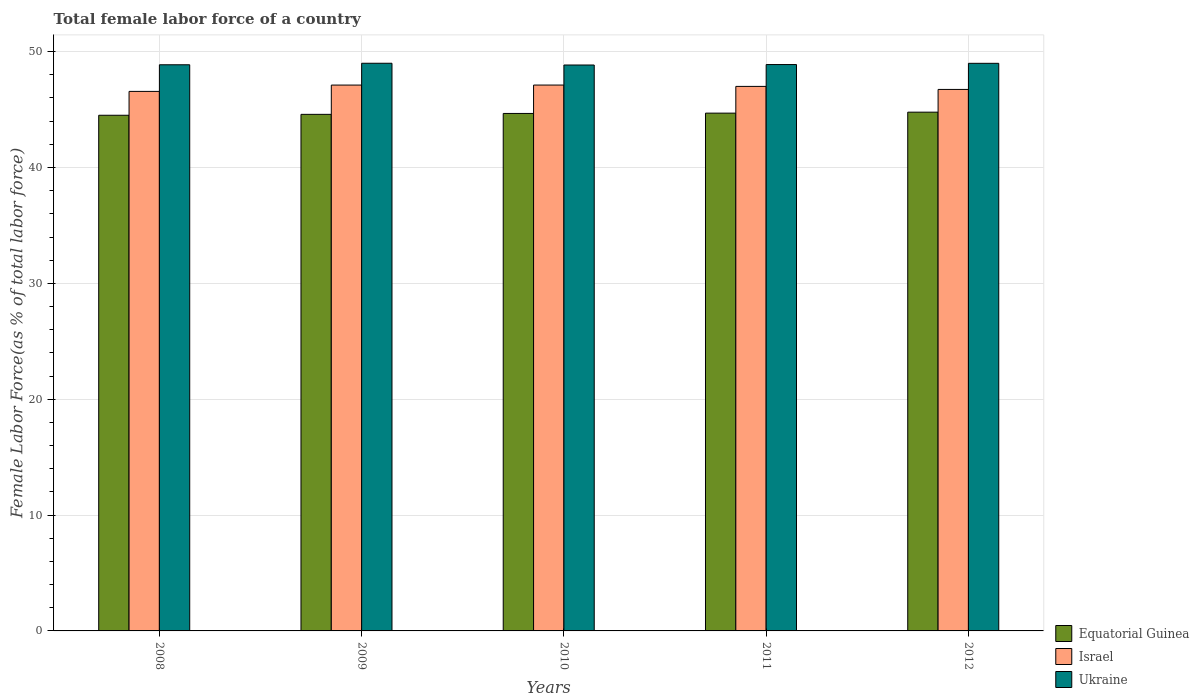How many different coloured bars are there?
Provide a succinct answer. 3. How many groups of bars are there?
Make the answer very short. 5. Are the number of bars per tick equal to the number of legend labels?
Provide a short and direct response. Yes. Are the number of bars on each tick of the X-axis equal?
Keep it short and to the point. Yes. How many bars are there on the 3rd tick from the left?
Your answer should be compact. 3. How many bars are there on the 2nd tick from the right?
Your response must be concise. 3. What is the label of the 5th group of bars from the left?
Your answer should be compact. 2012. What is the percentage of female labor force in Equatorial Guinea in 2012?
Your answer should be very brief. 44.77. Across all years, what is the maximum percentage of female labor force in Equatorial Guinea?
Give a very brief answer. 44.77. Across all years, what is the minimum percentage of female labor force in Ukraine?
Keep it short and to the point. 48.85. In which year was the percentage of female labor force in Israel maximum?
Make the answer very short. 2010. In which year was the percentage of female labor force in Israel minimum?
Offer a very short reply. 2008. What is the total percentage of female labor force in Ukraine in the graph?
Ensure brevity in your answer.  244.58. What is the difference between the percentage of female labor force in Ukraine in 2009 and that in 2010?
Keep it short and to the point. 0.15. What is the difference between the percentage of female labor force in Ukraine in 2008 and the percentage of female labor force in Equatorial Guinea in 2009?
Provide a succinct answer. 4.28. What is the average percentage of female labor force in Israel per year?
Offer a very short reply. 46.91. In the year 2009, what is the difference between the percentage of female labor force in Ukraine and percentage of female labor force in Israel?
Ensure brevity in your answer.  1.88. In how many years, is the percentage of female labor force in Equatorial Guinea greater than 40 %?
Give a very brief answer. 5. What is the ratio of the percentage of female labor force in Equatorial Guinea in 2010 to that in 2011?
Your response must be concise. 1. Is the difference between the percentage of female labor force in Ukraine in 2010 and 2012 greater than the difference between the percentage of female labor force in Israel in 2010 and 2012?
Keep it short and to the point. No. What is the difference between the highest and the second highest percentage of female labor force in Equatorial Guinea?
Make the answer very short. 0.08. What is the difference between the highest and the lowest percentage of female labor force in Israel?
Keep it short and to the point. 0.55. In how many years, is the percentage of female labor force in Israel greater than the average percentage of female labor force in Israel taken over all years?
Ensure brevity in your answer.  3. Is the sum of the percentage of female labor force in Israel in 2011 and 2012 greater than the maximum percentage of female labor force in Ukraine across all years?
Your answer should be compact. Yes. What does the 1st bar from the left in 2008 represents?
Your answer should be compact. Equatorial Guinea. What does the 1st bar from the right in 2012 represents?
Make the answer very short. Ukraine. How many bars are there?
Provide a succinct answer. 15. What is the difference between two consecutive major ticks on the Y-axis?
Give a very brief answer. 10. How many legend labels are there?
Provide a short and direct response. 3. What is the title of the graph?
Your answer should be very brief. Total female labor force of a country. Does "Italy" appear as one of the legend labels in the graph?
Your response must be concise. No. What is the label or title of the Y-axis?
Your answer should be compact. Female Labor Force(as % of total labor force). What is the Female Labor Force(as % of total labor force) in Equatorial Guinea in 2008?
Keep it short and to the point. 44.51. What is the Female Labor Force(as % of total labor force) of Israel in 2008?
Make the answer very short. 46.57. What is the Female Labor Force(as % of total labor force) in Ukraine in 2008?
Provide a succinct answer. 48.87. What is the Female Labor Force(as % of total labor force) of Equatorial Guinea in 2009?
Keep it short and to the point. 44.59. What is the Female Labor Force(as % of total labor force) of Israel in 2009?
Offer a very short reply. 47.11. What is the Female Labor Force(as % of total labor force) in Ukraine in 2009?
Your answer should be compact. 49. What is the Female Labor Force(as % of total labor force) of Equatorial Guinea in 2010?
Ensure brevity in your answer.  44.66. What is the Female Labor Force(as % of total labor force) in Israel in 2010?
Offer a terse response. 47.11. What is the Female Labor Force(as % of total labor force) in Ukraine in 2010?
Ensure brevity in your answer.  48.85. What is the Female Labor Force(as % of total labor force) of Equatorial Guinea in 2011?
Give a very brief answer. 44.69. What is the Female Labor Force(as % of total labor force) in Israel in 2011?
Your answer should be very brief. 47. What is the Female Labor Force(as % of total labor force) in Ukraine in 2011?
Give a very brief answer. 48.88. What is the Female Labor Force(as % of total labor force) of Equatorial Guinea in 2012?
Your answer should be compact. 44.77. What is the Female Labor Force(as % of total labor force) in Israel in 2012?
Offer a terse response. 46.74. What is the Female Labor Force(as % of total labor force) of Ukraine in 2012?
Provide a succinct answer. 48.99. Across all years, what is the maximum Female Labor Force(as % of total labor force) in Equatorial Guinea?
Provide a short and direct response. 44.77. Across all years, what is the maximum Female Labor Force(as % of total labor force) in Israel?
Your answer should be very brief. 47.11. Across all years, what is the maximum Female Labor Force(as % of total labor force) in Ukraine?
Make the answer very short. 49. Across all years, what is the minimum Female Labor Force(as % of total labor force) in Equatorial Guinea?
Provide a succinct answer. 44.51. Across all years, what is the minimum Female Labor Force(as % of total labor force) in Israel?
Ensure brevity in your answer.  46.57. Across all years, what is the minimum Female Labor Force(as % of total labor force) in Ukraine?
Offer a terse response. 48.85. What is the total Female Labor Force(as % of total labor force) of Equatorial Guinea in the graph?
Offer a terse response. 223.22. What is the total Female Labor Force(as % of total labor force) of Israel in the graph?
Make the answer very short. 234.53. What is the total Female Labor Force(as % of total labor force) of Ukraine in the graph?
Your answer should be very brief. 244.58. What is the difference between the Female Labor Force(as % of total labor force) of Equatorial Guinea in 2008 and that in 2009?
Your response must be concise. -0.08. What is the difference between the Female Labor Force(as % of total labor force) in Israel in 2008 and that in 2009?
Provide a succinct answer. -0.55. What is the difference between the Female Labor Force(as % of total labor force) of Ukraine in 2008 and that in 2009?
Your answer should be compact. -0.13. What is the difference between the Female Labor Force(as % of total labor force) in Equatorial Guinea in 2008 and that in 2010?
Your answer should be very brief. -0.16. What is the difference between the Female Labor Force(as % of total labor force) of Israel in 2008 and that in 2010?
Your response must be concise. -0.55. What is the difference between the Female Labor Force(as % of total labor force) in Ukraine in 2008 and that in 2010?
Make the answer very short. 0.02. What is the difference between the Female Labor Force(as % of total labor force) in Equatorial Guinea in 2008 and that in 2011?
Your response must be concise. -0.18. What is the difference between the Female Labor Force(as % of total labor force) of Israel in 2008 and that in 2011?
Make the answer very short. -0.43. What is the difference between the Female Labor Force(as % of total labor force) in Ukraine in 2008 and that in 2011?
Provide a succinct answer. -0.02. What is the difference between the Female Labor Force(as % of total labor force) of Equatorial Guinea in 2008 and that in 2012?
Provide a short and direct response. -0.27. What is the difference between the Female Labor Force(as % of total labor force) of Israel in 2008 and that in 2012?
Your answer should be compact. -0.17. What is the difference between the Female Labor Force(as % of total labor force) of Ukraine in 2008 and that in 2012?
Provide a short and direct response. -0.12. What is the difference between the Female Labor Force(as % of total labor force) of Equatorial Guinea in 2009 and that in 2010?
Your answer should be very brief. -0.08. What is the difference between the Female Labor Force(as % of total labor force) of Israel in 2009 and that in 2010?
Give a very brief answer. -0. What is the difference between the Female Labor Force(as % of total labor force) in Ukraine in 2009 and that in 2010?
Your answer should be very brief. 0.15. What is the difference between the Female Labor Force(as % of total labor force) of Equatorial Guinea in 2009 and that in 2011?
Keep it short and to the point. -0.11. What is the difference between the Female Labor Force(as % of total labor force) of Israel in 2009 and that in 2011?
Your answer should be compact. 0.12. What is the difference between the Female Labor Force(as % of total labor force) of Ukraine in 2009 and that in 2011?
Your answer should be very brief. 0.11. What is the difference between the Female Labor Force(as % of total labor force) in Equatorial Guinea in 2009 and that in 2012?
Give a very brief answer. -0.19. What is the difference between the Female Labor Force(as % of total labor force) in Israel in 2009 and that in 2012?
Give a very brief answer. 0.38. What is the difference between the Female Labor Force(as % of total labor force) in Ukraine in 2009 and that in 2012?
Ensure brevity in your answer.  0.01. What is the difference between the Female Labor Force(as % of total labor force) of Equatorial Guinea in 2010 and that in 2011?
Provide a succinct answer. -0.03. What is the difference between the Female Labor Force(as % of total labor force) in Israel in 2010 and that in 2011?
Your answer should be very brief. 0.12. What is the difference between the Female Labor Force(as % of total labor force) in Ukraine in 2010 and that in 2011?
Your answer should be very brief. -0.04. What is the difference between the Female Labor Force(as % of total labor force) in Equatorial Guinea in 2010 and that in 2012?
Provide a short and direct response. -0.11. What is the difference between the Female Labor Force(as % of total labor force) of Israel in 2010 and that in 2012?
Offer a terse response. 0.38. What is the difference between the Female Labor Force(as % of total labor force) in Ukraine in 2010 and that in 2012?
Offer a very short reply. -0.14. What is the difference between the Female Labor Force(as % of total labor force) of Equatorial Guinea in 2011 and that in 2012?
Your answer should be very brief. -0.08. What is the difference between the Female Labor Force(as % of total labor force) of Israel in 2011 and that in 2012?
Offer a very short reply. 0.26. What is the difference between the Female Labor Force(as % of total labor force) of Ukraine in 2011 and that in 2012?
Your answer should be very brief. -0.11. What is the difference between the Female Labor Force(as % of total labor force) of Equatorial Guinea in 2008 and the Female Labor Force(as % of total labor force) of Israel in 2009?
Provide a short and direct response. -2.61. What is the difference between the Female Labor Force(as % of total labor force) in Equatorial Guinea in 2008 and the Female Labor Force(as % of total labor force) in Ukraine in 2009?
Your answer should be compact. -4.49. What is the difference between the Female Labor Force(as % of total labor force) of Israel in 2008 and the Female Labor Force(as % of total labor force) of Ukraine in 2009?
Your response must be concise. -2.43. What is the difference between the Female Labor Force(as % of total labor force) of Equatorial Guinea in 2008 and the Female Labor Force(as % of total labor force) of Israel in 2010?
Your response must be concise. -2.61. What is the difference between the Female Labor Force(as % of total labor force) in Equatorial Guinea in 2008 and the Female Labor Force(as % of total labor force) in Ukraine in 2010?
Offer a terse response. -4.34. What is the difference between the Female Labor Force(as % of total labor force) of Israel in 2008 and the Female Labor Force(as % of total labor force) of Ukraine in 2010?
Keep it short and to the point. -2.28. What is the difference between the Female Labor Force(as % of total labor force) in Equatorial Guinea in 2008 and the Female Labor Force(as % of total labor force) in Israel in 2011?
Keep it short and to the point. -2.49. What is the difference between the Female Labor Force(as % of total labor force) in Equatorial Guinea in 2008 and the Female Labor Force(as % of total labor force) in Ukraine in 2011?
Give a very brief answer. -4.38. What is the difference between the Female Labor Force(as % of total labor force) in Israel in 2008 and the Female Labor Force(as % of total labor force) in Ukraine in 2011?
Provide a short and direct response. -2.32. What is the difference between the Female Labor Force(as % of total labor force) in Equatorial Guinea in 2008 and the Female Labor Force(as % of total labor force) in Israel in 2012?
Give a very brief answer. -2.23. What is the difference between the Female Labor Force(as % of total labor force) in Equatorial Guinea in 2008 and the Female Labor Force(as % of total labor force) in Ukraine in 2012?
Your answer should be very brief. -4.48. What is the difference between the Female Labor Force(as % of total labor force) in Israel in 2008 and the Female Labor Force(as % of total labor force) in Ukraine in 2012?
Give a very brief answer. -2.42. What is the difference between the Female Labor Force(as % of total labor force) of Equatorial Guinea in 2009 and the Female Labor Force(as % of total labor force) of Israel in 2010?
Provide a short and direct response. -2.53. What is the difference between the Female Labor Force(as % of total labor force) in Equatorial Guinea in 2009 and the Female Labor Force(as % of total labor force) in Ukraine in 2010?
Offer a very short reply. -4.26. What is the difference between the Female Labor Force(as % of total labor force) in Israel in 2009 and the Female Labor Force(as % of total labor force) in Ukraine in 2010?
Give a very brief answer. -1.73. What is the difference between the Female Labor Force(as % of total labor force) in Equatorial Guinea in 2009 and the Female Labor Force(as % of total labor force) in Israel in 2011?
Your response must be concise. -2.41. What is the difference between the Female Labor Force(as % of total labor force) in Equatorial Guinea in 2009 and the Female Labor Force(as % of total labor force) in Ukraine in 2011?
Keep it short and to the point. -4.3. What is the difference between the Female Labor Force(as % of total labor force) of Israel in 2009 and the Female Labor Force(as % of total labor force) of Ukraine in 2011?
Provide a short and direct response. -1.77. What is the difference between the Female Labor Force(as % of total labor force) of Equatorial Guinea in 2009 and the Female Labor Force(as % of total labor force) of Israel in 2012?
Offer a very short reply. -2.15. What is the difference between the Female Labor Force(as % of total labor force) in Equatorial Guinea in 2009 and the Female Labor Force(as % of total labor force) in Ukraine in 2012?
Your answer should be compact. -4.4. What is the difference between the Female Labor Force(as % of total labor force) of Israel in 2009 and the Female Labor Force(as % of total labor force) of Ukraine in 2012?
Your response must be concise. -1.88. What is the difference between the Female Labor Force(as % of total labor force) in Equatorial Guinea in 2010 and the Female Labor Force(as % of total labor force) in Israel in 2011?
Provide a short and direct response. -2.33. What is the difference between the Female Labor Force(as % of total labor force) in Equatorial Guinea in 2010 and the Female Labor Force(as % of total labor force) in Ukraine in 2011?
Provide a succinct answer. -4.22. What is the difference between the Female Labor Force(as % of total labor force) in Israel in 2010 and the Female Labor Force(as % of total labor force) in Ukraine in 2011?
Ensure brevity in your answer.  -1.77. What is the difference between the Female Labor Force(as % of total labor force) in Equatorial Guinea in 2010 and the Female Labor Force(as % of total labor force) in Israel in 2012?
Make the answer very short. -2.07. What is the difference between the Female Labor Force(as % of total labor force) in Equatorial Guinea in 2010 and the Female Labor Force(as % of total labor force) in Ukraine in 2012?
Keep it short and to the point. -4.33. What is the difference between the Female Labor Force(as % of total labor force) of Israel in 2010 and the Female Labor Force(as % of total labor force) of Ukraine in 2012?
Your answer should be compact. -1.88. What is the difference between the Female Labor Force(as % of total labor force) of Equatorial Guinea in 2011 and the Female Labor Force(as % of total labor force) of Israel in 2012?
Keep it short and to the point. -2.05. What is the difference between the Female Labor Force(as % of total labor force) in Equatorial Guinea in 2011 and the Female Labor Force(as % of total labor force) in Ukraine in 2012?
Offer a terse response. -4.3. What is the difference between the Female Labor Force(as % of total labor force) in Israel in 2011 and the Female Labor Force(as % of total labor force) in Ukraine in 2012?
Provide a succinct answer. -1.99. What is the average Female Labor Force(as % of total labor force) in Equatorial Guinea per year?
Provide a short and direct response. 44.64. What is the average Female Labor Force(as % of total labor force) in Israel per year?
Provide a short and direct response. 46.91. What is the average Female Labor Force(as % of total labor force) of Ukraine per year?
Keep it short and to the point. 48.92. In the year 2008, what is the difference between the Female Labor Force(as % of total labor force) in Equatorial Guinea and Female Labor Force(as % of total labor force) in Israel?
Offer a very short reply. -2.06. In the year 2008, what is the difference between the Female Labor Force(as % of total labor force) in Equatorial Guinea and Female Labor Force(as % of total labor force) in Ukraine?
Provide a succinct answer. -4.36. In the year 2008, what is the difference between the Female Labor Force(as % of total labor force) of Israel and Female Labor Force(as % of total labor force) of Ukraine?
Make the answer very short. -2.3. In the year 2009, what is the difference between the Female Labor Force(as % of total labor force) of Equatorial Guinea and Female Labor Force(as % of total labor force) of Israel?
Offer a terse response. -2.53. In the year 2009, what is the difference between the Female Labor Force(as % of total labor force) in Equatorial Guinea and Female Labor Force(as % of total labor force) in Ukraine?
Provide a short and direct response. -4.41. In the year 2009, what is the difference between the Female Labor Force(as % of total labor force) of Israel and Female Labor Force(as % of total labor force) of Ukraine?
Your answer should be very brief. -1.88. In the year 2010, what is the difference between the Female Labor Force(as % of total labor force) of Equatorial Guinea and Female Labor Force(as % of total labor force) of Israel?
Provide a short and direct response. -2.45. In the year 2010, what is the difference between the Female Labor Force(as % of total labor force) of Equatorial Guinea and Female Labor Force(as % of total labor force) of Ukraine?
Provide a succinct answer. -4.18. In the year 2010, what is the difference between the Female Labor Force(as % of total labor force) of Israel and Female Labor Force(as % of total labor force) of Ukraine?
Make the answer very short. -1.73. In the year 2011, what is the difference between the Female Labor Force(as % of total labor force) of Equatorial Guinea and Female Labor Force(as % of total labor force) of Israel?
Provide a short and direct response. -2.31. In the year 2011, what is the difference between the Female Labor Force(as % of total labor force) in Equatorial Guinea and Female Labor Force(as % of total labor force) in Ukraine?
Keep it short and to the point. -4.19. In the year 2011, what is the difference between the Female Labor Force(as % of total labor force) in Israel and Female Labor Force(as % of total labor force) in Ukraine?
Keep it short and to the point. -1.89. In the year 2012, what is the difference between the Female Labor Force(as % of total labor force) in Equatorial Guinea and Female Labor Force(as % of total labor force) in Israel?
Your response must be concise. -1.96. In the year 2012, what is the difference between the Female Labor Force(as % of total labor force) in Equatorial Guinea and Female Labor Force(as % of total labor force) in Ukraine?
Provide a short and direct response. -4.22. In the year 2012, what is the difference between the Female Labor Force(as % of total labor force) in Israel and Female Labor Force(as % of total labor force) in Ukraine?
Provide a succinct answer. -2.25. What is the ratio of the Female Labor Force(as % of total labor force) in Equatorial Guinea in 2008 to that in 2009?
Your response must be concise. 1. What is the ratio of the Female Labor Force(as % of total labor force) in Israel in 2008 to that in 2009?
Your answer should be compact. 0.99. What is the ratio of the Female Labor Force(as % of total labor force) in Equatorial Guinea in 2008 to that in 2010?
Make the answer very short. 1. What is the ratio of the Female Labor Force(as % of total labor force) of Israel in 2008 to that in 2010?
Make the answer very short. 0.99. What is the ratio of the Female Labor Force(as % of total labor force) in Israel in 2008 to that in 2011?
Provide a succinct answer. 0.99. What is the ratio of the Female Labor Force(as % of total labor force) in Equatorial Guinea in 2008 to that in 2012?
Keep it short and to the point. 0.99. What is the ratio of the Female Labor Force(as % of total labor force) in Israel in 2008 to that in 2012?
Make the answer very short. 1. What is the ratio of the Female Labor Force(as % of total labor force) in Equatorial Guinea in 2009 to that in 2011?
Your answer should be very brief. 1. What is the ratio of the Female Labor Force(as % of total labor force) of Israel in 2009 to that in 2011?
Offer a terse response. 1. What is the ratio of the Female Labor Force(as % of total labor force) in Ukraine in 2009 to that in 2011?
Give a very brief answer. 1. What is the ratio of the Female Labor Force(as % of total labor force) in Equatorial Guinea in 2009 to that in 2012?
Make the answer very short. 1. What is the ratio of the Female Labor Force(as % of total labor force) in Ukraine in 2009 to that in 2012?
Give a very brief answer. 1. What is the ratio of the Female Labor Force(as % of total labor force) in Israel in 2010 to that in 2011?
Provide a short and direct response. 1. What is the ratio of the Female Labor Force(as % of total labor force) in Equatorial Guinea in 2010 to that in 2012?
Keep it short and to the point. 1. What is the ratio of the Female Labor Force(as % of total labor force) in Equatorial Guinea in 2011 to that in 2012?
Your answer should be compact. 1. What is the ratio of the Female Labor Force(as % of total labor force) of Israel in 2011 to that in 2012?
Your response must be concise. 1.01. What is the ratio of the Female Labor Force(as % of total labor force) of Ukraine in 2011 to that in 2012?
Make the answer very short. 1. What is the difference between the highest and the second highest Female Labor Force(as % of total labor force) in Equatorial Guinea?
Your answer should be compact. 0.08. What is the difference between the highest and the second highest Female Labor Force(as % of total labor force) in Israel?
Provide a succinct answer. 0. What is the difference between the highest and the second highest Female Labor Force(as % of total labor force) of Ukraine?
Provide a short and direct response. 0.01. What is the difference between the highest and the lowest Female Labor Force(as % of total labor force) of Equatorial Guinea?
Provide a succinct answer. 0.27. What is the difference between the highest and the lowest Female Labor Force(as % of total labor force) in Israel?
Make the answer very short. 0.55. What is the difference between the highest and the lowest Female Labor Force(as % of total labor force) of Ukraine?
Your answer should be compact. 0.15. 